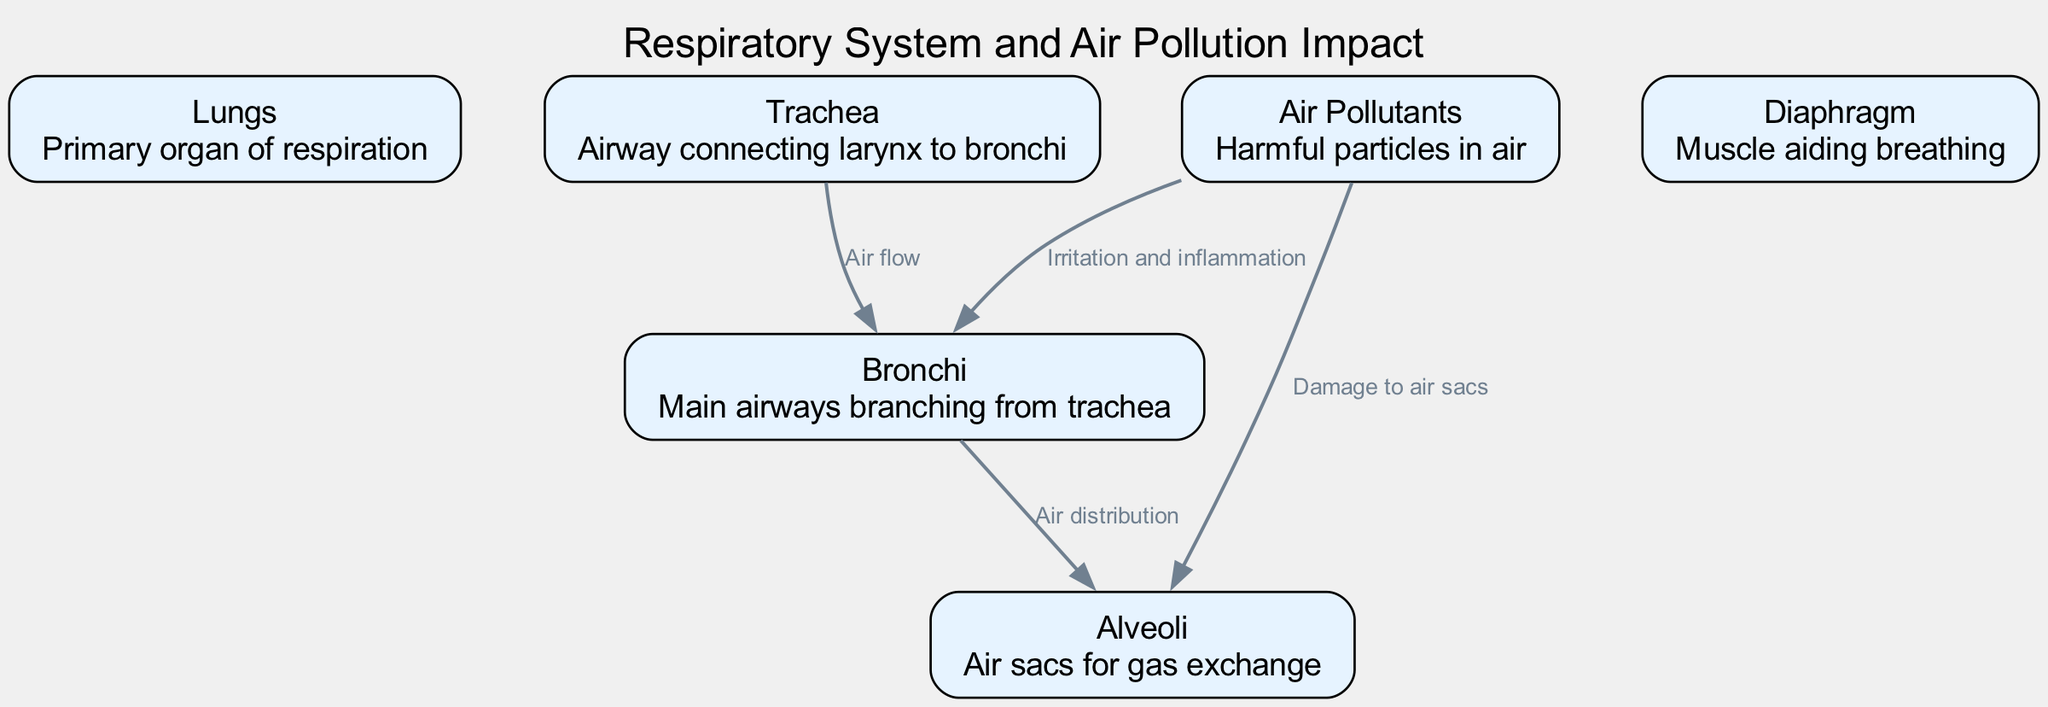What is the primary organ of respiration? The diagram indicates that the "Lungs" is labeled as the primary organ of respiration. Thus, looking for the node that describes the organ responsible for breathing, we find that it is the "Lungs."
Answer: Lungs How many nodes are present in the diagram? To answer this, we count the nodes listed in the data: "Lungs," "Trachea," "Bronchi," "Alveoli," "Diaphragm," and "Air Pollutants," totaling six distinct nodes.
Answer: 6 What is the effect of air pollutants on the alveoli? The diagram shows a direct connection where "Air Pollutants" flows to "Alveoli" and is labeled as "Damage to air sacs," indicating that pollutants harm these structures specifically.
Answer: Damage to air sacs What is the relationship between the trachea and bronchi? The diagram has an edge connecting "Trachea" to "Bronchi" labeled as "Air flow," indicating that air moves from the trachea into the bronchi.
Answer: Air flow Which muscle aids in breathing? The "Diaphragm" is specifically described in the diagram as the muscle that aids breathing, making it the necessary answer to identify the respiratory muscle.
Answer: Diaphragm What does air pollution cause in the bronchi? According to the diagram, "Air Pollutants" have a labeled effect labeled as "Irritation and inflammation" directed towards the "Bronchi," indicating the specific harm that pollutants inflict on these passageways.
Answer: Irritation and inflammation What connects the bronchi to the alveoli? The connection is depicted in the diagram with an edge labeled "Air distribution," showing that air travels from the bronchi to the alveoli, which are responsible for gas exchange.
Answer: Air distribution How does air pollution affect lung health? The diagram illustrates that "Air Pollutants" damage the "Alveoli" and cause "Irritation and inflammation" in the "Bronchi," indicating multiple detrimental impacts on lung health brought on by pollution.
Answer: Damage to air sacs and irritation What color represents the nodes in the diagram? From the data provided, the color specified for the nodes is "#4682B4," indicating the visual appearance of the nodes in the rendered diagram.
Answer: #4682B4 